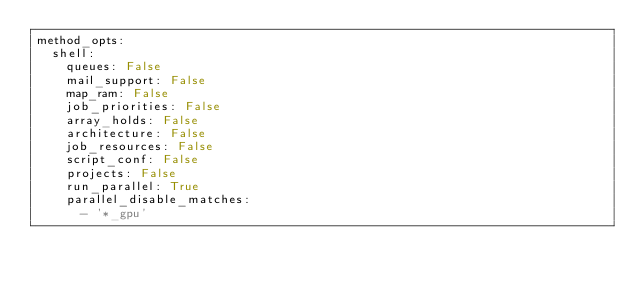Convert code to text. <code><loc_0><loc_0><loc_500><loc_500><_YAML_>method_opts:
  shell:
    queues: False
    mail_support: False
    map_ram: False
    job_priorities: False
    array_holds: False
    architecture: False
    job_resources: False
    script_conf: False
    projects: False
    run_parallel: True
    parallel_disable_matches:
      - '*_gpu'
</code> 